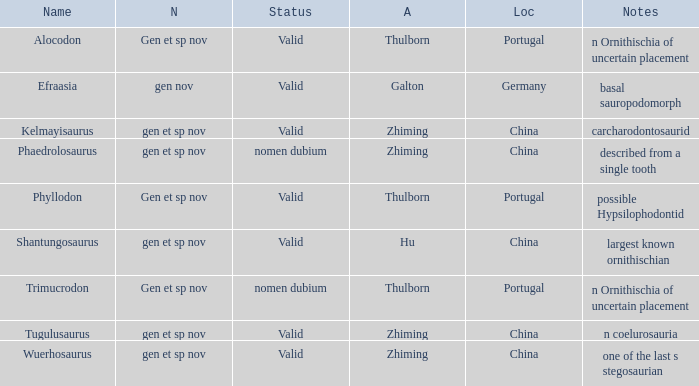What are the Notes of the dinosaur, whose Status is nomen dubium, and whose Location is China? Described from a single tooth. 